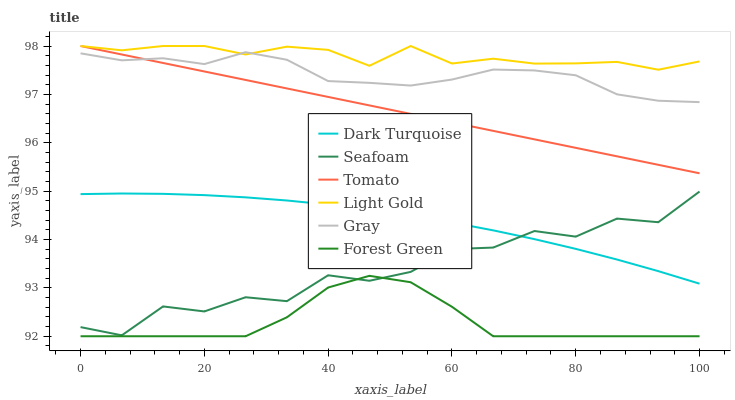Does Forest Green have the minimum area under the curve?
Answer yes or no. Yes. Does Light Gold have the maximum area under the curve?
Answer yes or no. Yes. Does Gray have the minimum area under the curve?
Answer yes or no. No. Does Gray have the maximum area under the curve?
Answer yes or no. No. Is Tomato the smoothest?
Answer yes or no. Yes. Is Seafoam the roughest?
Answer yes or no. Yes. Is Gray the smoothest?
Answer yes or no. No. Is Gray the roughest?
Answer yes or no. No. Does Forest Green have the lowest value?
Answer yes or no. Yes. Does Gray have the lowest value?
Answer yes or no. No. Does Light Gold have the highest value?
Answer yes or no. Yes. Does Gray have the highest value?
Answer yes or no. No. Is Seafoam less than Tomato?
Answer yes or no. Yes. Is Light Gold greater than Forest Green?
Answer yes or no. Yes. Does Light Gold intersect Tomato?
Answer yes or no. Yes. Is Light Gold less than Tomato?
Answer yes or no. No. Is Light Gold greater than Tomato?
Answer yes or no. No. Does Seafoam intersect Tomato?
Answer yes or no. No. 